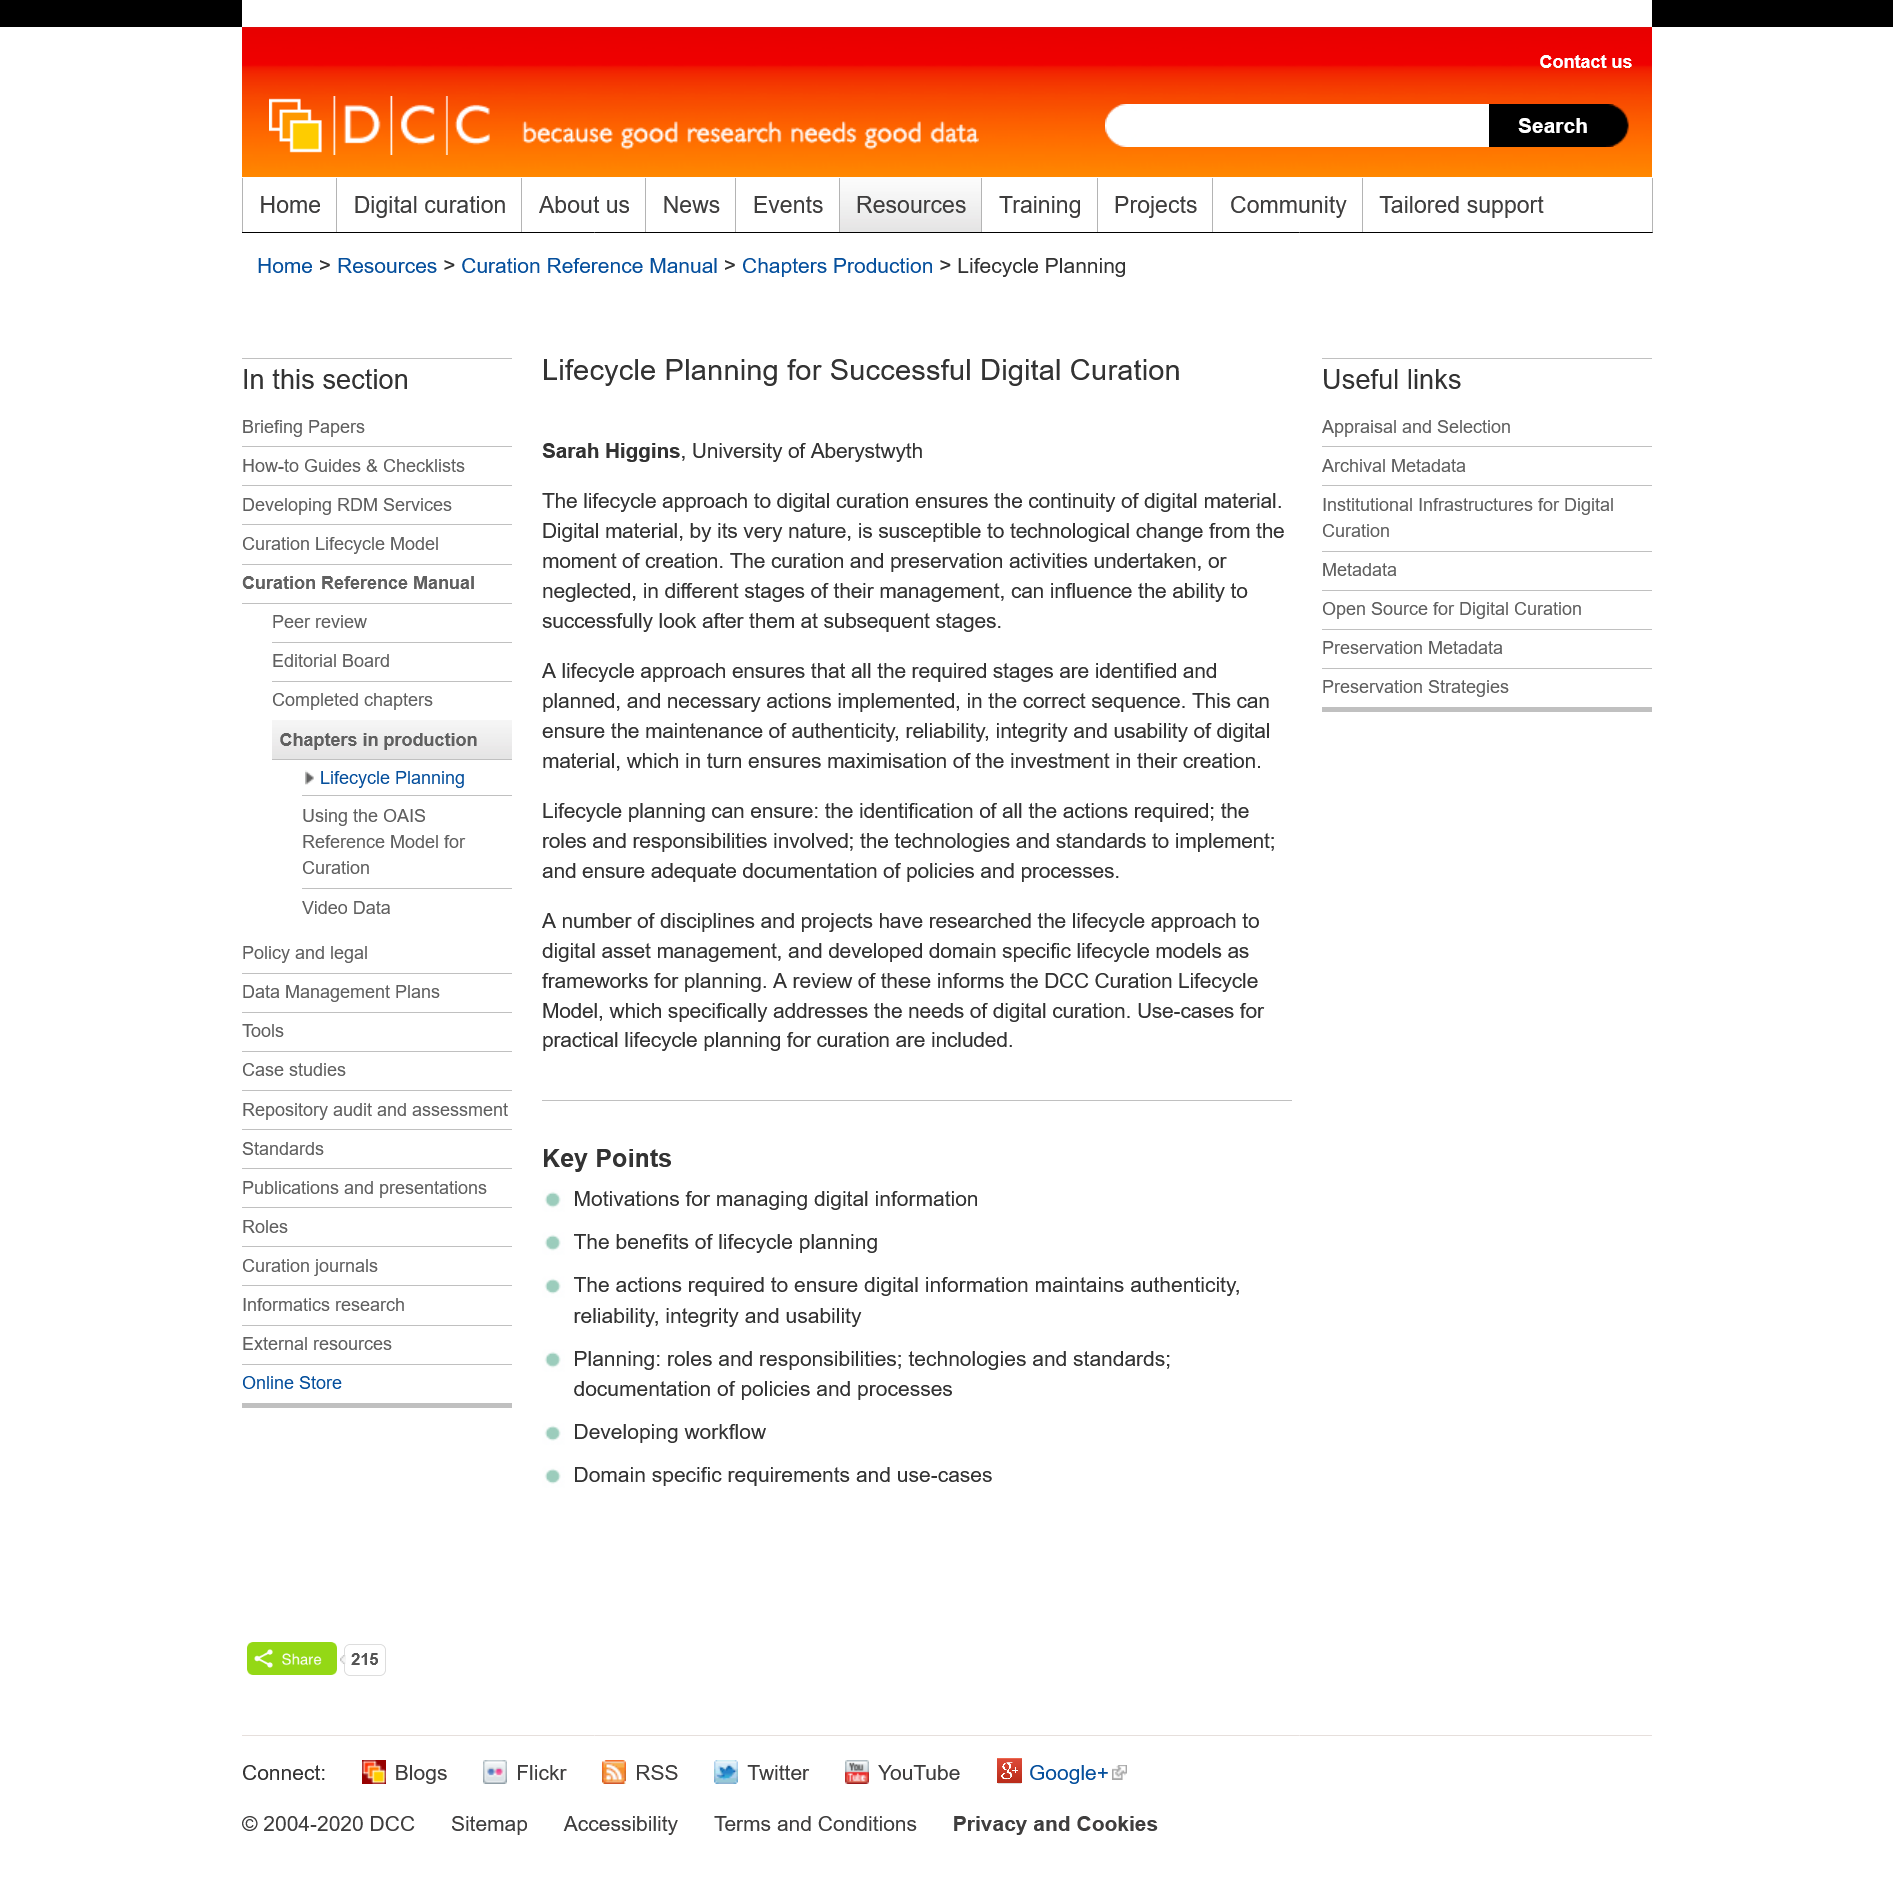Draw attention to some important aspects in this diagram. The creator of this page is Sarah Higgins. This page is titled "Lifecycle Planning for Successful Digital Curation". Sarah Higgins taught at the University of Aberystwyth. 